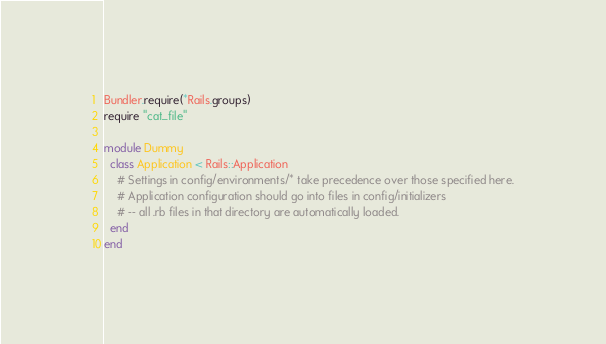<code> <loc_0><loc_0><loc_500><loc_500><_Ruby_>
Bundler.require(*Rails.groups)
require "cat_file"

module Dummy
  class Application < Rails::Application
    # Settings in config/environments/* take precedence over those specified here.
    # Application configuration should go into files in config/initializers
    # -- all .rb files in that directory are automatically loaded.
  end
end

</code> 